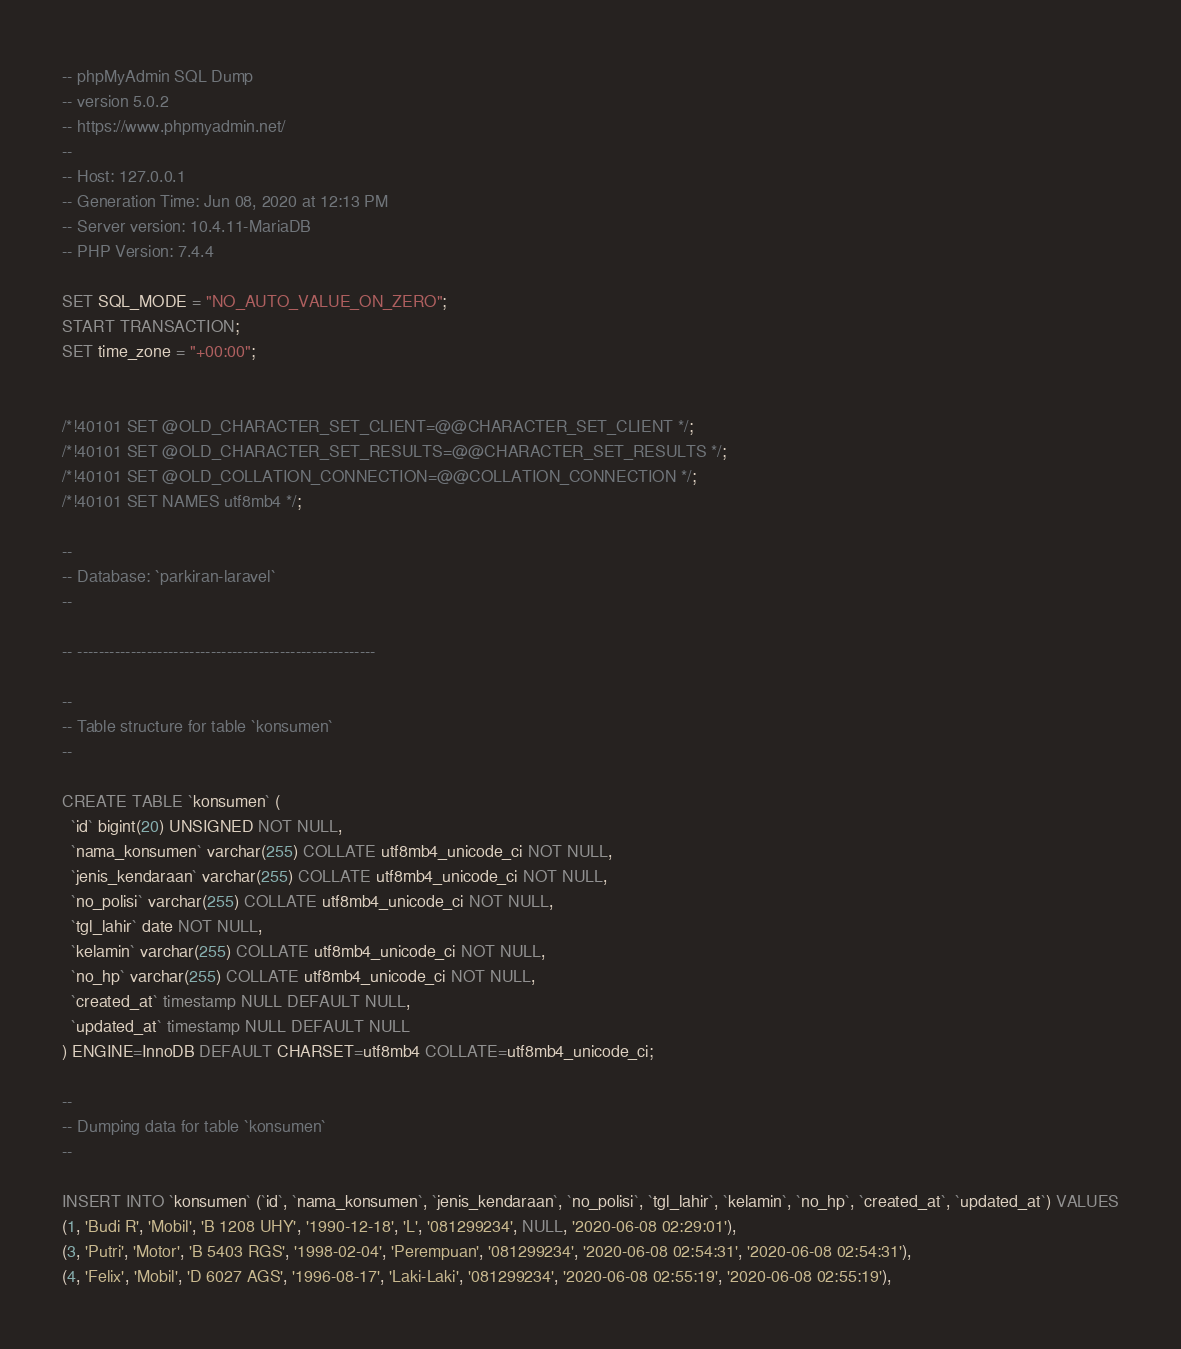Convert code to text. <code><loc_0><loc_0><loc_500><loc_500><_SQL_>-- phpMyAdmin SQL Dump
-- version 5.0.2
-- https://www.phpmyadmin.net/
--
-- Host: 127.0.0.1
-- Generation Time: Jun 08, 2020 at 12:13 PM
-- Server version: 10.4.11-MariaDB
-- PHP Version: 7.4.4

SET SQL_MODE = "NO_AUTO_VALUE_ON_ZERO";
START TRANSACTION;
SET time_zone = "+00:00";


/*!40101 SET @OLD_CHARACTER_SET_CLIENT=@@CHARACTER_SET_CLIENT */;
/*!40101 SET @OLD_CHARACTER_SET_RESULTS=@@CHARACTER_SET_RESULTS */;
/*!40101 SET @OLD_COLLATION_CONNECTION=@@COLLATION_CONNECTION */;
/*!40101 SET NAMES utf8mb4 */;

--
-- Database: `parkiran-laravel`
--

-- --------------------------------------------------------

--
-- Table structure for table `konsumen`
--

CREATE TABLE `konsumen` (
  `id` bigint(20) UNSIGNED NOT NULL,
  `nama_konsumen` varchar(255) COLLATE utf8mb4_unicode_ci NOT NULL,
  `jenis_kendaraan` varchar(255) COLLATE utf8mb4_unicode_ci NOT NULL,
  `no_polisi` varchar(255) COLLATE utf8mb4_unicode_ci NOT NULL,
  `tgl_lahir` date NOT NULL,
  `kelamin` varchar(255) COLLATE utf8mb4_unicode_ci NOT NULL,
  `no_hp` varchar(255) COLLATE utf8mb4_unicode_ci NOT NULL,
  `created_at` timestamp NULL DEFAULT NULL,
  `updated_at` timestamp NULL DEFAULT NULL
) ENGINE=InnoDB DEFAULT CHARSET=utf8mb4 COLLATE=utf8mb4_unicode_ci;

--
-- Dumping data for table `konsumen`
--

INSERT INTO `konsumen` (`id`, `nama_konsumen`, `jenis_kendaraan`, `no_polisi`, `tgl_lahir`, `kelamin`, `no_hp`, `created_at`, `updated_at`) VALUES
(1, 'Budi R', 'Mobil', 'B 1208 UHY', '1990-12-18', 'L', '081299234', NULL, '2020-06-08 02:29:01'),
(3, 'Putri', 'Motor', 'B 5403 RGS', '1998-02-04', 'Perempuan', '081299234', '2020-06-08 02:54:31', '2020-06-08 02:54:31'),
(4, 'Felix', 'Mobil', 'D 6027 AGS', '1996-08-17', 'Laki-Laki', '081299234', '2020-06-08 02:55:19', '2020-06-08 02:55:19'),</code> 